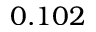Convert formula to latex. <formula><loc_0><loc_0><loc_500><loc_500>0 . 1 0 2</formula> 